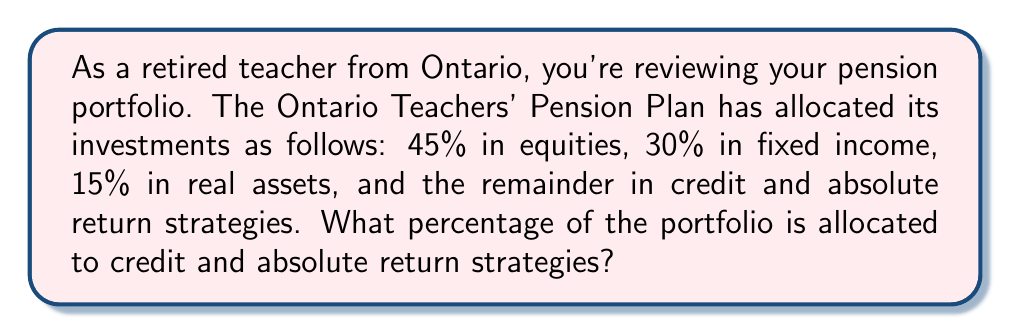Provide a solution to this math problem. To solve this problem, we need to follow these steps:

1. Identify the known allocations:
   - Equities: 45%
   - Fixed income: 30%
   - Real assets: 15%

2. Calculate the total percentage of known allocations:
   $$45\% + 30\% + 15\% = 90\%$$

3. Determine the remaining percentage:
   Since the total allocation must equal 100%, we can subtract the known allocations from 100%:
   $$100\% - 90\% = 10\%$$

This remaining 10% represents the allocation to credit and absolute return strategies.
Answer: The percentage of the portfolio allocated to credit and absolute return strategies is 10%. 